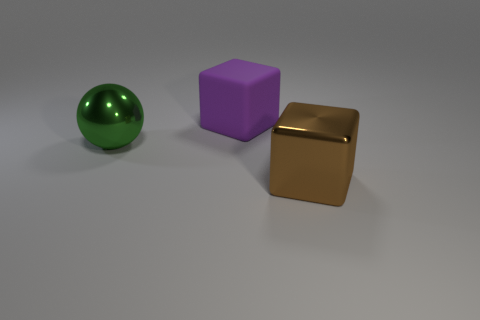What color is the rubber thing that is the same shape as the brown metal thing?
Offer a terse response. Purple. Do the purple matte block and the brown block have the same size?
Provide a succinct answer. Yes. There is a metallic ball; is its size the same as the block behind the large brown cube?
Offer a terse response. Yes. There is a large object that is behind the brown metal cube and in front of the rubber block; what color is it?
Your response must be concise. Green. Are there more brown cubes that are in front of the brown metallic object than brown things in front of the ball?
Your answer should be very brief. No. There is a brown object that is the same material as the green thing; what size is it?
Your answer should be very brief. Large. There is a large block that is behind the big brown object; how many large brown objects are on the left side of it?
Your answer should be compact. 0. Is there a big brown shiny object of the same shape as the matte object?
Your answer should be compact. Yes. There is a thing that is on the right side of the cube that is behind the large green metallic thing; what is its color?
Provide a short and direct response. Brown. Are there more big purple shiny cylinders than large brown blocks?
Offer a very short reply. No. 